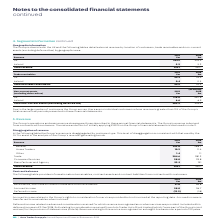According to Auto Trader's financial document, What does accrued income relate to? Group’s rights to consideration for services provided but not invoiced at the reporting date. Accrued income is transferred to receivables when invoiced.. The document states: "Accrued income relates to the Group’s rights to consideration for services provided but not invoiced at the reporting date. Accrued income is transfer..." Also, What was  Accrued income in 2019? According to the financial document, 28.0 (in millions). The relevant text states: "Accrued income 28.0 26.7..." Also, What are the components in the table providing information on contract balances? The document contains multiple relevant values: Receivables, which are included in trade and other receivables, Accrued income, Deferred income. From the document: "Deferred income (13.2) (1.8) Accrued income 28.0 26.7 Receivables, which are included in trade and other receivables 27.0 28.8..." Additionally, In which year was accrued income larger? According to the financial document, 2019. The relevant text states: "Revenue 2019 £m 2018 £m..." Also, can you calculate: What was the change in accrued income in 2019 from 2018? Based on the calculation: 28.0-26.7, the result is 1.3 (in millions). This is based on the information: "Accrued income 28.0 26.7 Accrued income 28.0 26.7..." The key data points involved are: 26.7, 28.0. Also, can you calculate: What was the percentage change in accrued income in 2019 from 2018? To answer this question, I need to perform calculations using the financial data. The calculation is: (28.0-26.7)/26.7, which equals 4.87 (percentage). This is based on the information: "Accrued income 28.0 26.7 Accrued income 28.0 26.7..." The key data points involved are: 26.7, 28.0. 